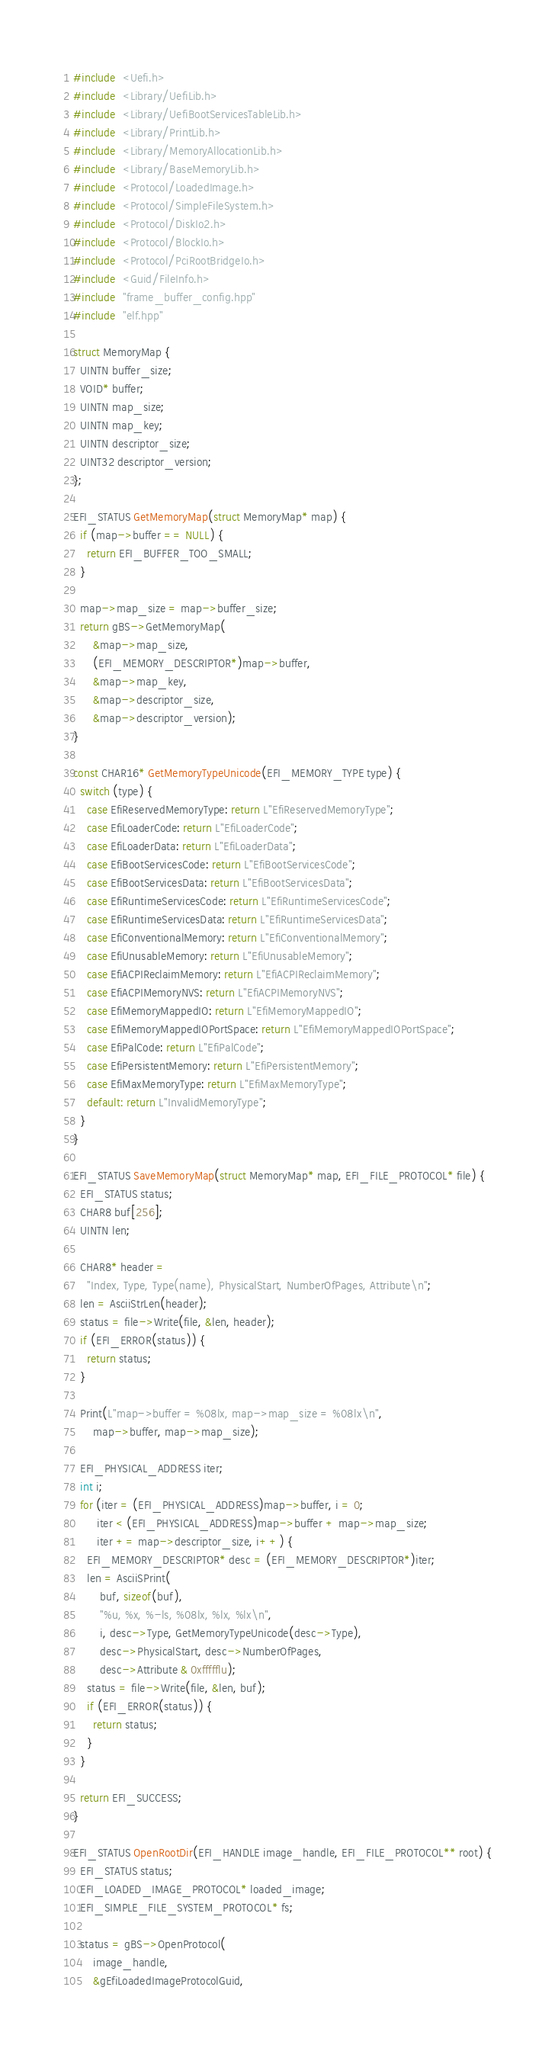Convert code to text. <code><loc_0><loc_0><loc_500><loc_500><_C_>#include  <Uefi.h>
#include  <Library/UefiLib.h>
#include  <Library/UefiBootServicesTableLib.h>
#include  <Library/PrintLib.h>
#include  <Library/MemoryAllocationLib.h>
#include  <Library/BaseMemoryLib.h>
#include  <Protocol/LoadedImage.h>
#include  <Protocol/SimpleFileSystem.h>
#include  <Protocol/DiskIo2.h>
#include  <Protocol/BlockIo.h>
#include  <Protocol/PciRootBridgeIo.h>
#include  <Guid/FileInfo.h>
#include  "frame_buffer_config.hpp"
#include  "elf.hpp"

struct MemoryMap {
  UINTN buffer_size;
  VOID* buffer;
  UINTN map_size;
  UINTN map_key;
  UINTN descriptor_size;
  UINT32 descriptor_version;
};

EFI_STATUS GetMemoryMap(struct MemoryMap* map) {
  if (map->buffer == NULL) {
    return EFI_BUFFER_TOO_SMALL;
  }

  map->map_size = map->buffer_size;
  return gBS->GetMemoryMap(
      &map->map_size,
      (EFI_MEMORY_DESCRIPTOR*)map->buffer,
      &map->map_key,
      &map->descriptor_size,
      &map->descriptor_version);
}

const CHAR16* GetMemoryTypeUnicode(EFI_MEMORY_TYPE type) {
  switch (type) {
    case EfiReservedMemoryType: return L"EfiReservedMemoryType";
    case EfiLoaderCode: return L"EfiLoaderCode";
    case EfiLoaderData: return L"EfiLoaderData";
    case EfiBootServicesCode: return L"EfiBootServicesCode";
    case EfiBootServicesData: return L"EfiBootServicesData";
    case EfiRuntimeServicesCode: return L"EfiRuntimeServicesCode";
    case EfiRuntimeServicesData: return L"EfiRuntimeServicesData";
    case EfiConventionalMemory: return L"EfiConventionalMemory";
    case EfiUnusableMemory: return L"EfiUnusableMemory";
    case EfiACPIReclaimMemory: return L"EfiACPIReclaimMemory";
    case EfiACPIMemoryNVS: return L"EfiACPIMemoryNVS";
    case EfiMemoryMappedIO: return L"EfiMemoryMappedIO";
    case EfiMemoryMappedIOPortSpace: return L"EfiMemoryMappedIOPortSpace";
    case EfiPalCode: return L"EfiPalCode";
    case EfiPersistentMemory: return L"EfiPersistentMemory";
    case EfiMaxMemoryType: return L"EfiMaxMemoryType";
    default: return L"InvalidMemoryType";
  }
}

EFI_STATUS SaveMemoryMap(struct MemoryMap* map, EFI_FILE_PROTOCOL* file) {
  EFI_STATUS status;
  CHAR8 buf[256];
  UINTN len;

  CHAR8* header =
    "Index, Type, Type(name), PhysicalStart, NumberOfPages, Attribute\n";
  len = AsciiStrLen(header);
  status = file->Write(file, &len, header);
  if (EFI_ERROR(status)) {
    return status;
  }

  Print(L"map->buffer = %08lx, map->map_size = %08lx\n",
      map->buffer, map->map_size);

  EFI_PHYSICAL_ADDRESS iter;
  int i;
  for (iter = (EFI_PHYSICAL_ADDRESS)map->buffer, i = 0;
       iter < (EFI_PHYSICAL_ADDRESS)map->buffer + map->map_size;
       iter += map->descriptor_size, i++) {
    EFI_MEMORY_DESCRIPTOR* desc = (EFI_MEMORY_DESCRIPTOR*)iter;
    len = AsciiSPrint(
        buf, sizeof(buf),
        "%u, %x, %-ls, %08lx, %lx, %lx\n",
        i, desc->Type, GetMemoryTypeUnicode(desc->Type),
        desc->PhysicalStart, desc->NumberOfPages,
        desc->Attribute & 0xffffflu);
    status = file->Write(file, &len, buf);
    if (EFI_ERROR(status)) {
      return status;
    }
  }

  return EFI_SUCCESS;
}

EFI_STATUS OpenRootDir(EFI_HANDLE image_handle, EFI_FILE_PROTOCOL** root) {
  EFI_STATUS status;
  EFI_LOADED_IMAGE_PROTOCOL* loaded_image;
  EFI_SIMPLE_FILE_SYSTEM_PROTOCOL* fs;

  status = gBS->OpenProtocol(
      image_handle,
      &gEfiLoadedImageProtocolGuid,</code> 